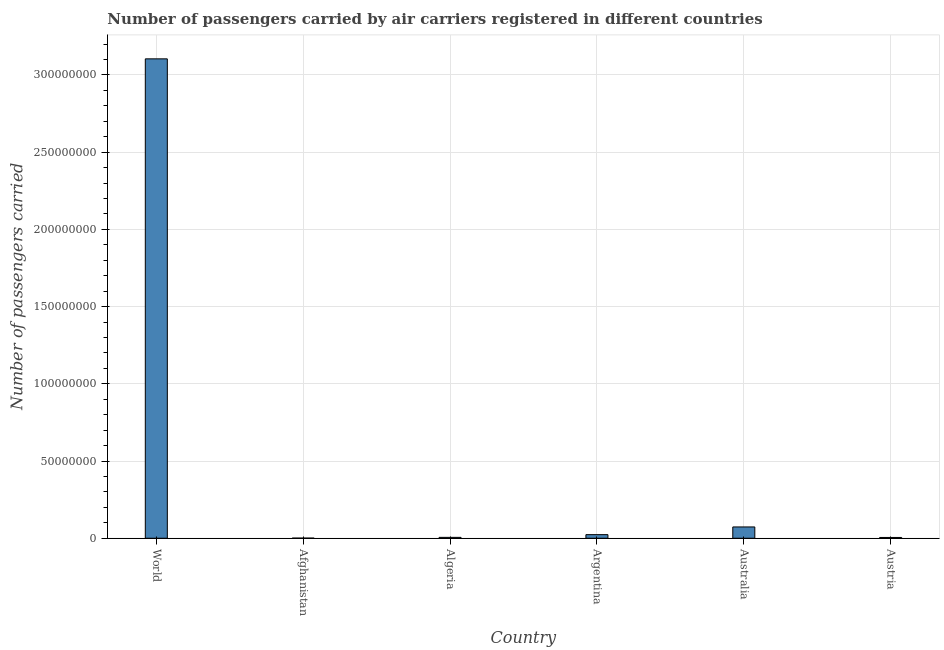Does the graph contain grids?
Provide a succinct answer. Yes. What is the title of the graph?
Your response must be concise. Number of passengers carried by air carriers registered in different countries. What is the label or title of the Y-axis?
Offer a very short reply. Number of passengers carried. What is the number of passengers carried in Australia?
Provide a succinct answer. 7.32e+06. Across all countries, what is the maximum number of passengers carried?
Provide a short and direct response. 3.10e+08. Across all countries, what is the minimum number of passengers carried?
Offer a terse response. 8.47e+04. In which country was the number of passengers carried maximum?
Your response must be concise. World. In which country was the number of passengers carried minimum?
Your response must be concise. Afghanistan. What is the sum of the number of passengers carried?
Your response must be concise. 3.21e+08. What is the difference between the number of passengers carried in Austria and World?
Make the answer very short. -3.10e+08. What is the average number of passengers carried per country?
Give a very brief answer. 5.35e+07. What is the median number of passengers carried?
Your response must be concise. 1.45e+06. In how many countries, is the number of passengers carried greater than 150000000 ?
Give a very brief answer. 1. What is the ratio of the number of passengers carried in Australia to that in World?
Provide a short and direct response. 0.02. Is the number of passengers carried in Argentina less than that in Australia?
Ensure brevity in your answer.  Yes. Is the difference between the number of passengers carried in Algeria and World greater than the difference between any two countries?
Make the answer very short. No. What is the difference between the highest and the second highest number of passengers carried?
Give a very brief answer. 3.03e+08. What is the difference between the highest and the lowest number of passengers carried?
Your answer should be compact. 3.10e+08. In how many countries, is the number of passengers carried greater than the average number of passengers carried taken over all countries?
Keep it short and to the point. 1. How many bars are there?
Your response must be concise. 6. How many countries are there in the graph?
Keep it short and to the point. 6. Are the values on the major ticks of Y-axis written in scientific E-notation?
Provide a succinct answer. No. What is the Number of passengers carried in World?
Offer a very short reply. 3.10e+08. What is the Number of passengers carried of Afghanistan?
Ensure brevity in your answer.  8.47e+04. What is the Number of passengers carried of Algeria?
Your answer should be compact. 5.63e+05. What is the Number of passengers carried of Argentina?
Provide a short and direct response. 2.33e+06. What is the Number of passengers carried of Australia?
Provide a succinct answer. 7.32e+06. What is the Number of passengers carried of Austria?
Your response must be concise. 5.11e+05. What is the difference between the Number of passengers carried in World and Afghanistan?
Offer a terse response. 3.10e+08. What is the difference between the Number of passengers carried in World and Algeria?
Provide a short and direct response. 3.10e+08. What is the difference between the Number of passengers carried in World and Argentina?
Your response must be concise. 3.08e+08. What is the difference between the Number of passengers carried in World and Australia?
Offer a very short reply. 3.03e+08. What is the difference between the Number of passengers carried in World and Austria?
Offer a very short reply. 3.10e+08. What is the difference between the Number of passengers carried in Afghanistan and Algeria?
Offer a terse response. -4.78e+05. What is the difference between the Number of passengers carried in Afghanistan and Argentina?
Ensure brevity in your answer.  -2.25e+06. What is the difference between the Number of passengers carried in Afghanistan and Australia?
Your answer should be compact. -7.23e+06. What is the difference between the Number of passengers carried in Afghanistan and Austria?
Make the answer very short. -4.27e+05. What is the difference between the Number of passengers carried in Algeria and Argentina?
Keep it short and to the point. -1.77e+06. What is the difference between the Number of passengers carried in Algeria and Australia?
Give a very brief answer. -6.76e+06. What is the difference between the Number of passengers carried in Algeria and Austria?
Offer a very short reply. 5.18e+04. What is the difference between the Number of passengers carried in Argentina and Australia?
Make the answer very short. -4.99e+06. What is the difference between the Number of passengers carried in Argentina and Austria?
Keep it short and to the point. 1.82e+06. What is the difference between the Number of passengers carried in Australia and Austria?
Provide a succinct answer. 6.81e+06. What is the ratio of the Number of passengers carried in World to that in Afghanistan?
Your answer should be compact. 3665.19. What is the ratio of the Number of passengers carried in World to that in Algeria?
Offer a terse response. 551.21. What is the ratio of the Number of passengers carried in World to that in Argentina?
Provide a short and direct response. 133.12. What is the ratio of the Number of passengers carried in World to that in Australia?
Provide a short and direct response. 42.42. What is the ratio of the Number of passengers carried in World to that in Austria?
Provide a succinct answer. 607.04. What is the ratio of the Number of passengers carried in Afghanistan to that in Algeria?
Offer a terse response. 0.15. What is the ratio of the Number of passengers carried in Afghanistan to that in Argentina?
Your answer should be compact. 0.04. What is the ratio of the Number of passengers carried in Afghanistan to that in Australia?
Provide a short and direct response. 0.01. What is the ratio of the Number of passengers carried in Afghanistan to that in Austria?
Your response must be concise. 0.17. What is the ratio of the Number of passengers carried in Algeria to that in Argentina?
Provide a succinct answer. 0.24. What is the ratio of the Number of passengers carried in Algeria to that in Australia?
Your answer should be very brief. 0.08. What is the ratio of the Number of passengers carried in Algeria to that in Austria?
Keep it short and to the point. 1.1. What is the ratio of the Number of passengers carried in Argentina to that in Australia?
Provide a succinct answer. 0.32. What is the ratio of the Number of passengers carried in Argentina to that in Austria?
Provide a short and direct response. 4.56. What is the ratio of the Number of passengers carried in Australia to that in Austria?
Keep it short and to the point. 14.31. 